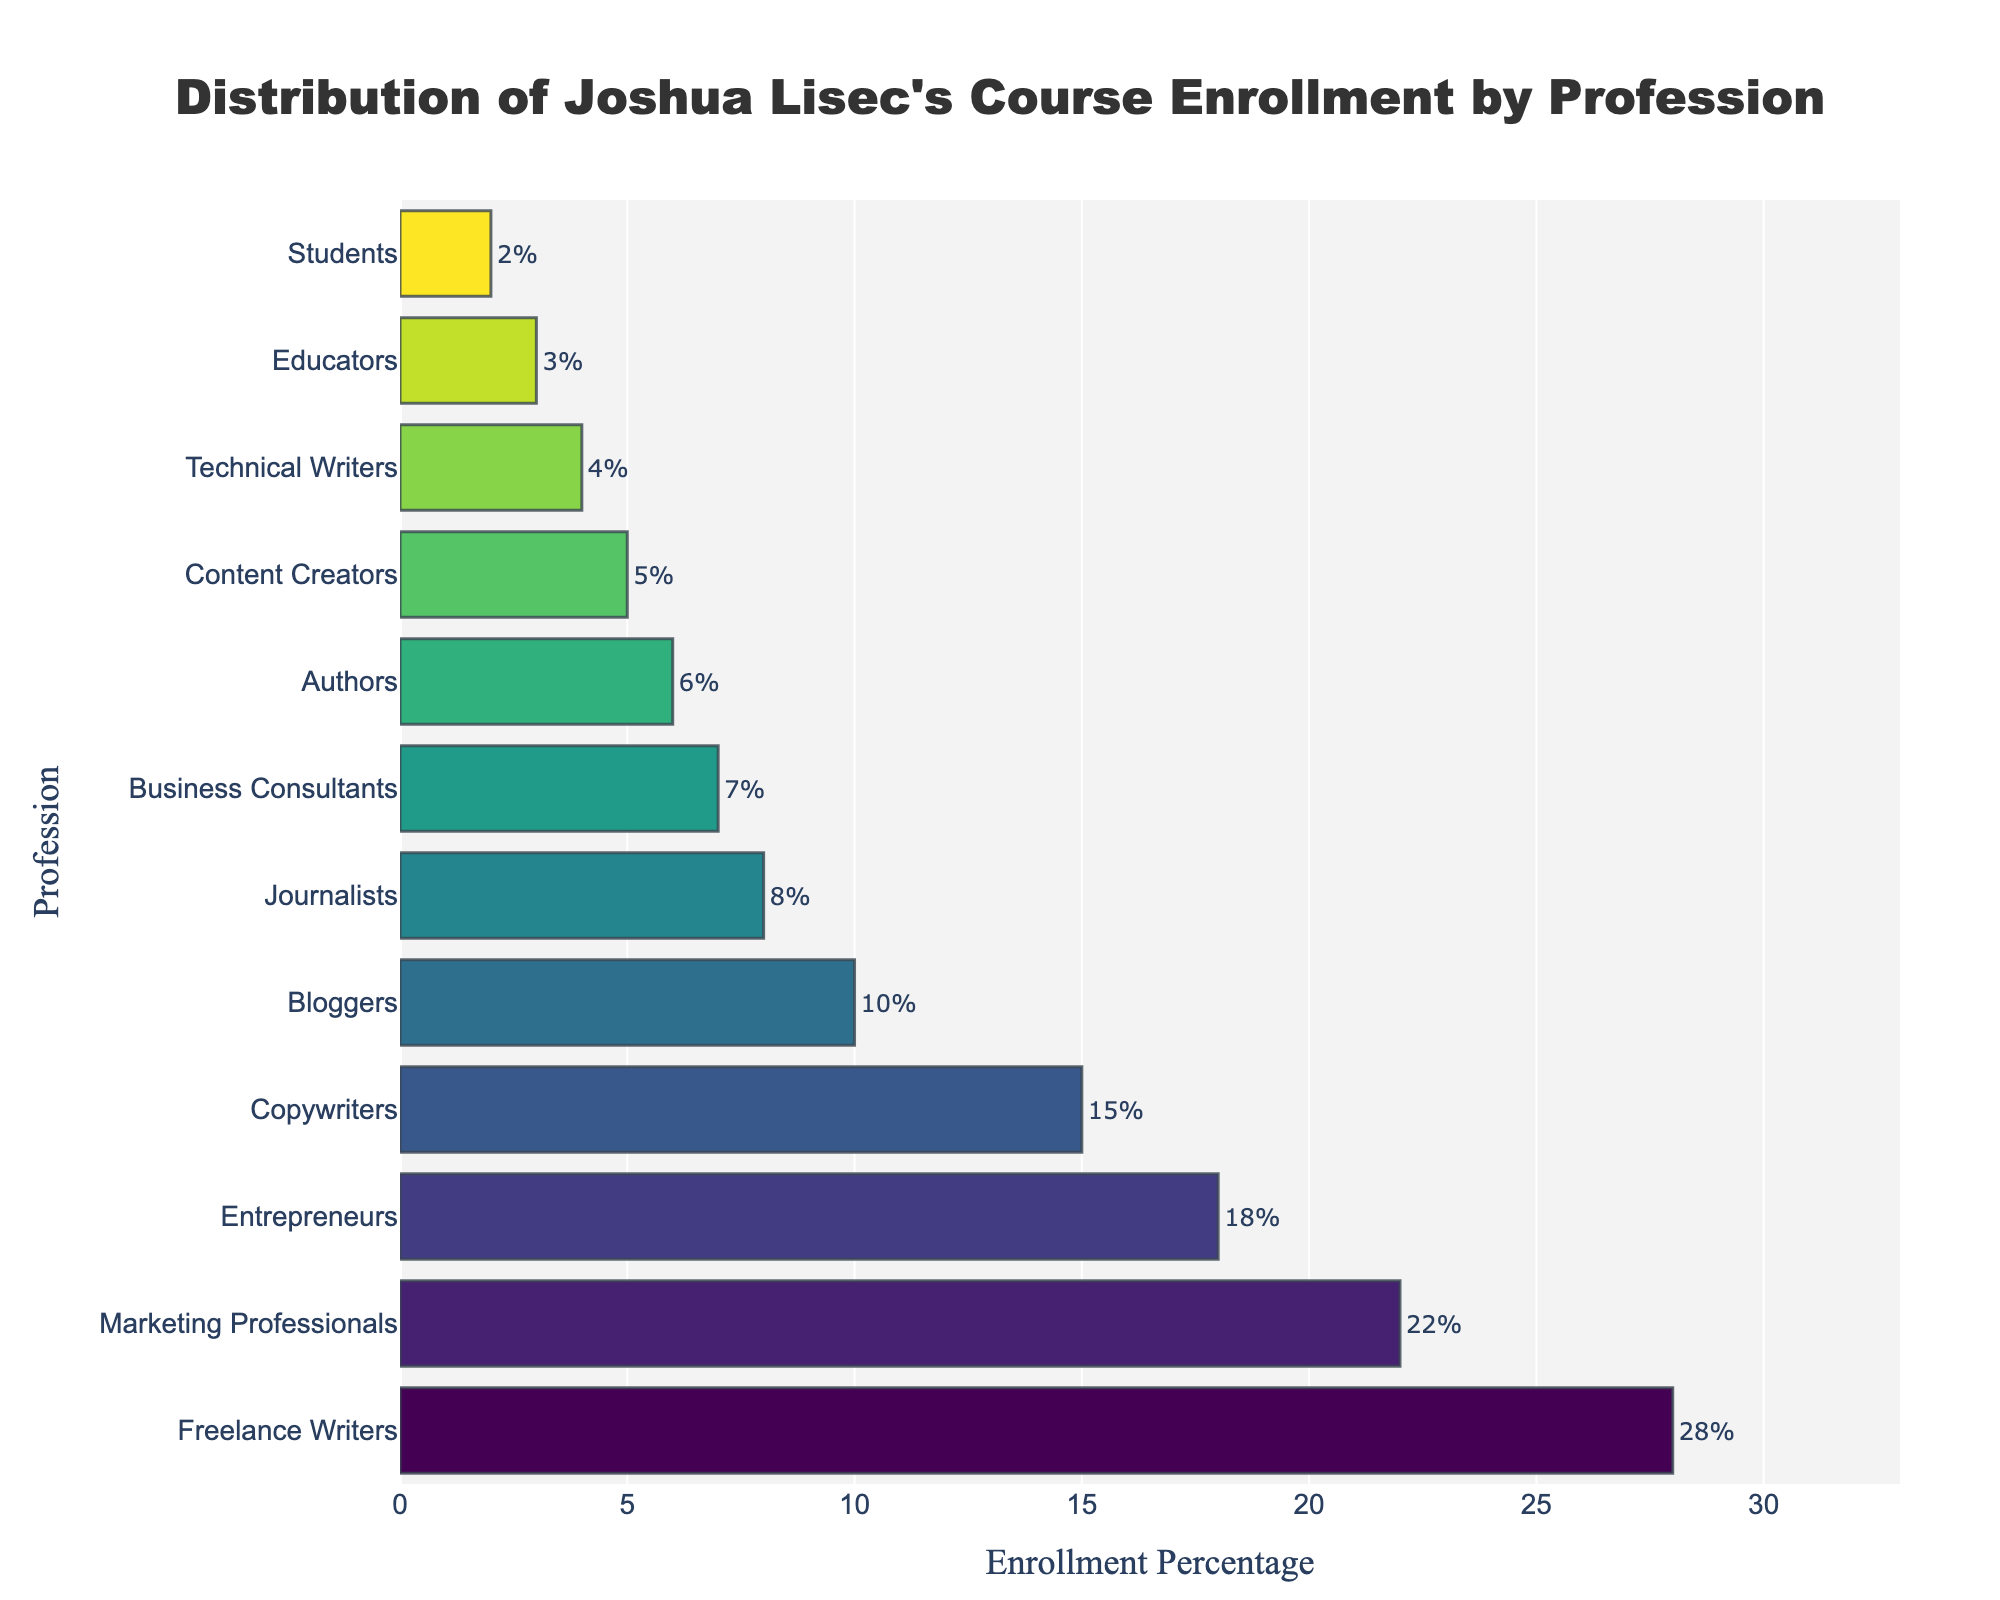Which profession has the highest enrollment percentage? By looking at the figure, the bar representing "Freelance Writers" is the longest, indicating the highest enrollment percentage.
Answer: Freelance Writers Which two professions have the closest enrollment percentages? "Authors" and "Content Creators" have enrollment percentages of 6% and 5%, respectively, which are the closest among all the data points.
Answer: Authors and Content Creators What's the percentage difference between the profession with the highest and the lowest enrollment? Freelance Writers have the highest enrollment percentage of 28%, and Students have the lowest at 2%. The difference is 28% - 2% = 26%.
Answer: 26% Rank the top three professions in terms of enrollment percentage. The top three bars in descending order of length represent "Freelance Writers" (28%), "Marketing Professionals" (22%), and "Entrepreneurs" (18%).
Answer: Freelance Writers, Marketing Professionals, Entrepreneurs How many professions have an enrollment percentage higher than 10%? The bars for "Freelance Writers", "Marketing Professionals", "Entrepreneurs", and "Copywriters" are all above the 10% mark.
Answer: 4 Which profession has a higher enrollment percentage: Journalists or Bloggers? By comparing the lengths of the bars, we see that "Bloggers" is slightly longer with 10% compared to "Journalists" at 8%.
Answer: Bloggers What is the total percentage of enrollment for "Educators", "Students", and "Technical Writers"? Summing up the enrollment percentages: Educators (3%) + Students (2%) + Technical Writers (4%) = 3% + 2% + 4% = 9%.
Answer: 9% Determine the average enrollment percentage of "Content Creators", "Authors", and "Business Consultants". Adding the values: 5% (Content Creators) + 6% (Authors) + 7% (Business Consultants) and then dividing by 3: (5 + 6 + 7)/3 = 18/3 = 6%.
Answer: 6% Compare the combined enrollment percentages of "Freelance Writers" and "Marketing Professionals" to that of "Bloggers", "Journalists", and "Business Consultants". Which is higher? Combining percentages for Freelance Writers and Marketing Professionals: 28% + 22% = 50%. Combining percentages for Bloggers, Journalists, and Business Consultants: 10% + 8% + 7% = 25%. 50% is higher than 25%.
Answer: Freelance Writers and Marketing Professionals What's the total enrollment percentage of professions with enrollment below 10%? Adding percentages for Content Creators (5%), Technical Writers (4%), Educators (3%), and Students (2%): 5% + 4% + 3% + 2% = 14%.
Answer: 14% 